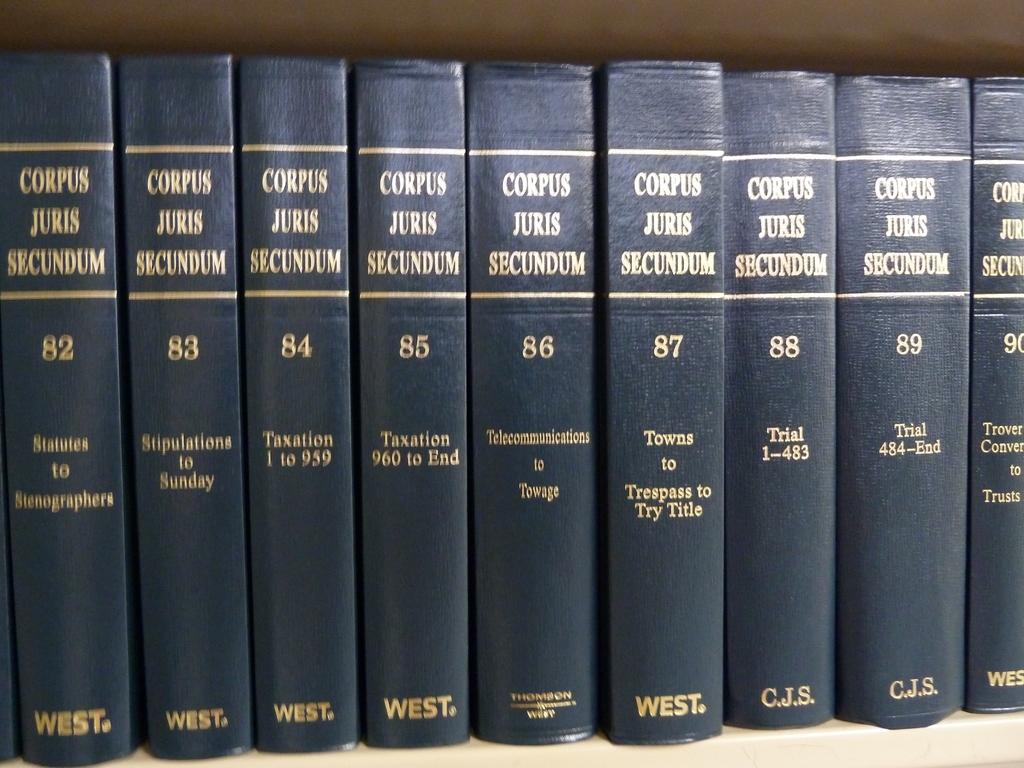What is the subject of  volume 85?
Provide a short and direct response. Taxation. 